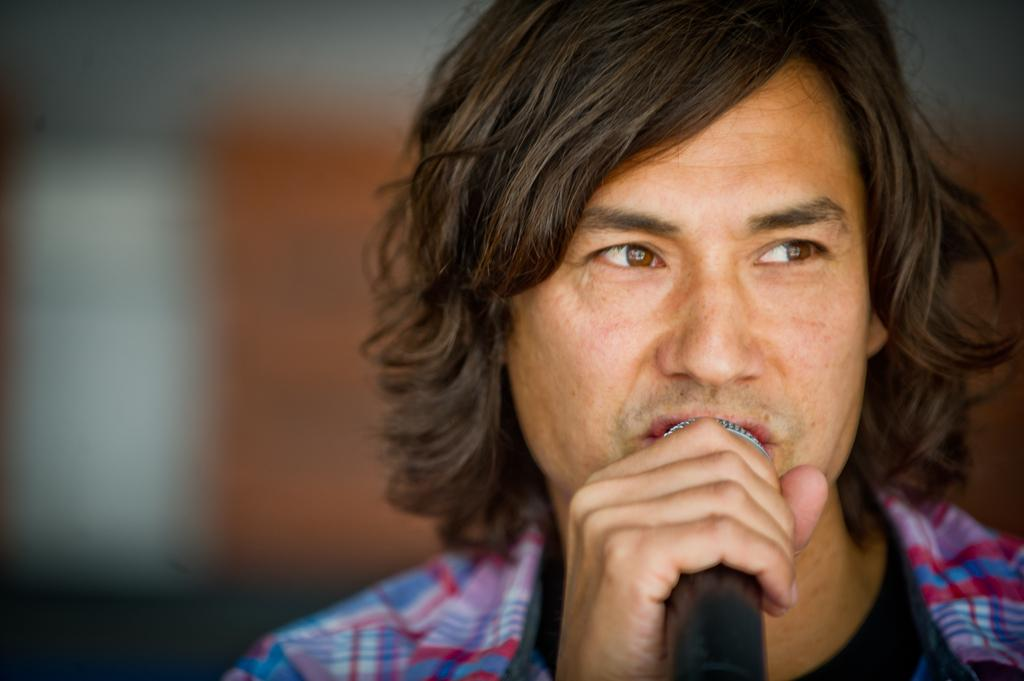Who or what is the main subject of the image? There is a person in the image. Can you describe the appearance of the person? The person has long hair and is wearing a dress. What is the person holding in their hands? The person is holding a microphone in their hands. How does the person's daughter interact with the flock of birds in the image? There is no daughter or flock of birds present in the image. 